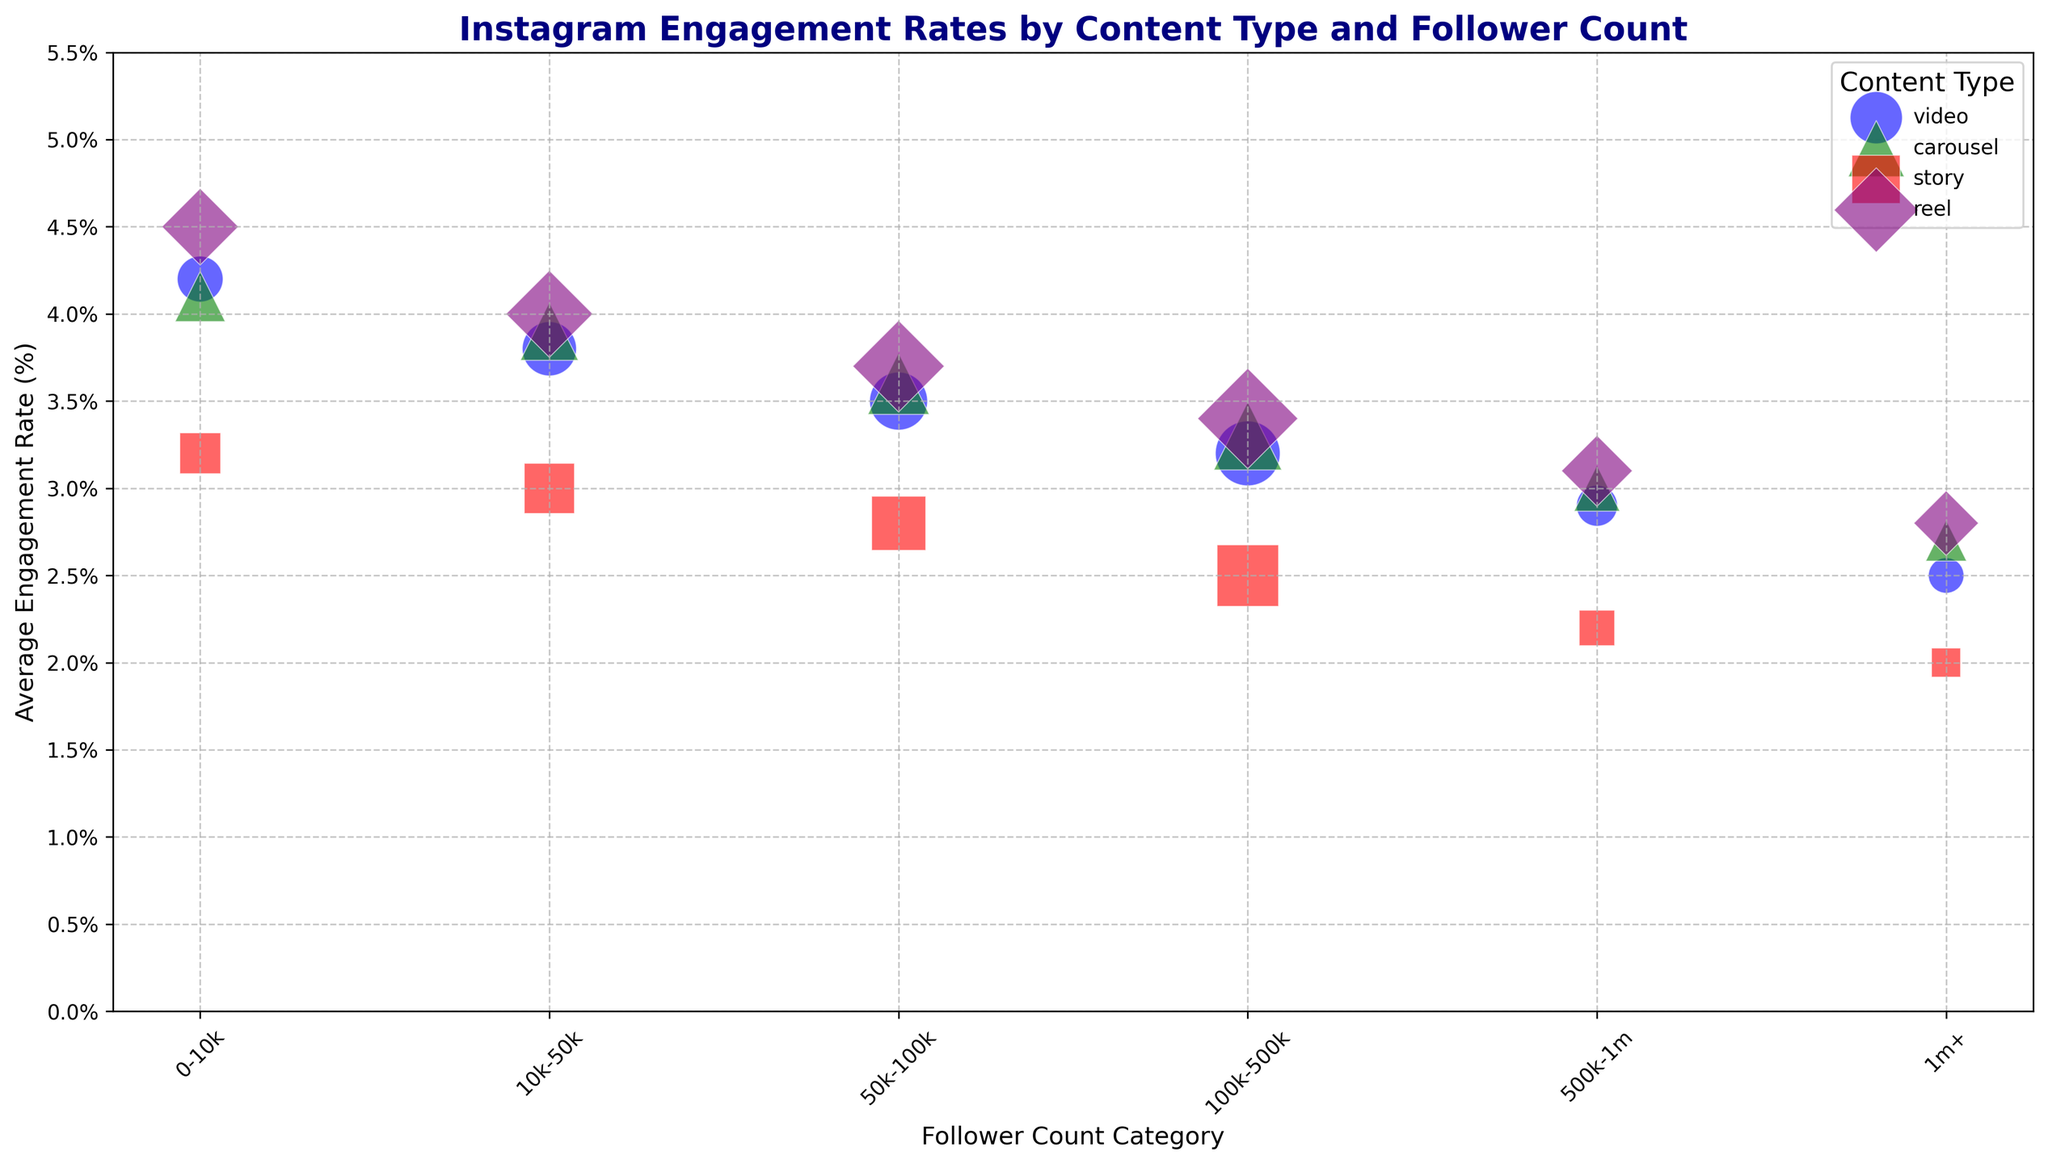What content type has the highest engagement rate for accounts with 0-10k followers? To determine this, find the average engagement rates for all content types within the 0-10k follower category. The engagement rates are: Video (4.2%), Carousel (4.1%), Story (3.2%), Reel (4.5%). The highest rate is for Reels at 4.5%.
Answer: Reel Which content type has the smallest size bubble for accounts with 500k-1m followers? Look for the size values for the 500k-1m follower count across all content types. The sizes are: Video (40), Carousel (50), Story (30), Reel (60). The smallest bubble corresponds to Stories.
Answer: Story Between videos and carousels, which content type generally has a higher engagement rate across all follower count categories? Compare the engagement rates for Videos and Carousels across all follower count categories: 0-10k (4.2 vs 4.1), 10k-50k (3.8 vs 3.9), 50k-100k (3.5 vs 3.6), 100k-500k (3.2 vs 3.3), 500k-1m (2.9 vs 3.0), 1m+ (2.5 vs 2.7). In each category, Carousels have slightly higher rates.
Answer: Carousel For accounts with 100k-500k followers, which content type has the highest engagement rate? Refer to engagement rates for 100k-500k followers: Video (3.2%), Carousel (3.3%), Story (2.5%), Reel (3.4%). The highest engagement rate is for Reels at 3.4%.
Answer: Reel What is the difference in engagement rate between the highest and lowest content types for the 1m+ follower category? Check the engagement rates for 1m+: Video (2.5%), Carousel (2.7%), Story (2.0%), Reel (2.8%). Calculate the difference between the highest (Reel 2.8%) and the lowest (Story 2.0%). The difference is 2.8% - 2.0% = 0.8%.
Answer: 0.8% Which follower count category has the most varied engagement rates within the same content type? Evaluate the range of engagement rates within follower categories for each content type: Video (1.7), Carousel (1.4), Story (1.2), Reel (1.7). Carousels have the smallest range, while Videos and Reels have the most varied (range of 1.7). Thus, Reels and Videos have the most varied (1.7).
Answer: Reel, Video 